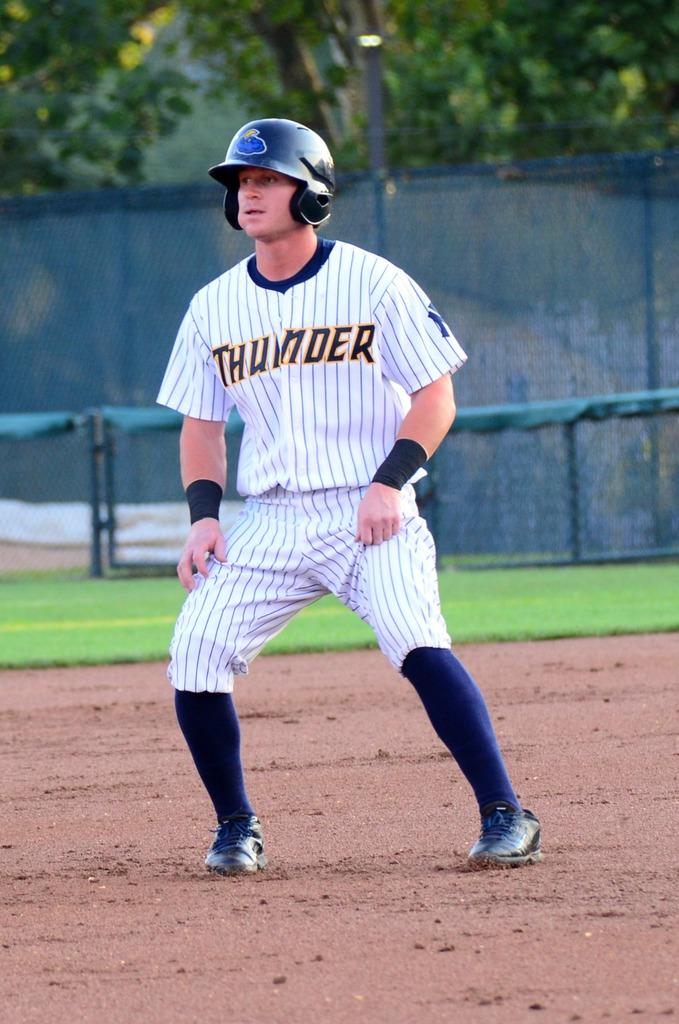<image>
Write a terse but informative summary of the picture. a Thunder player that is on the field 